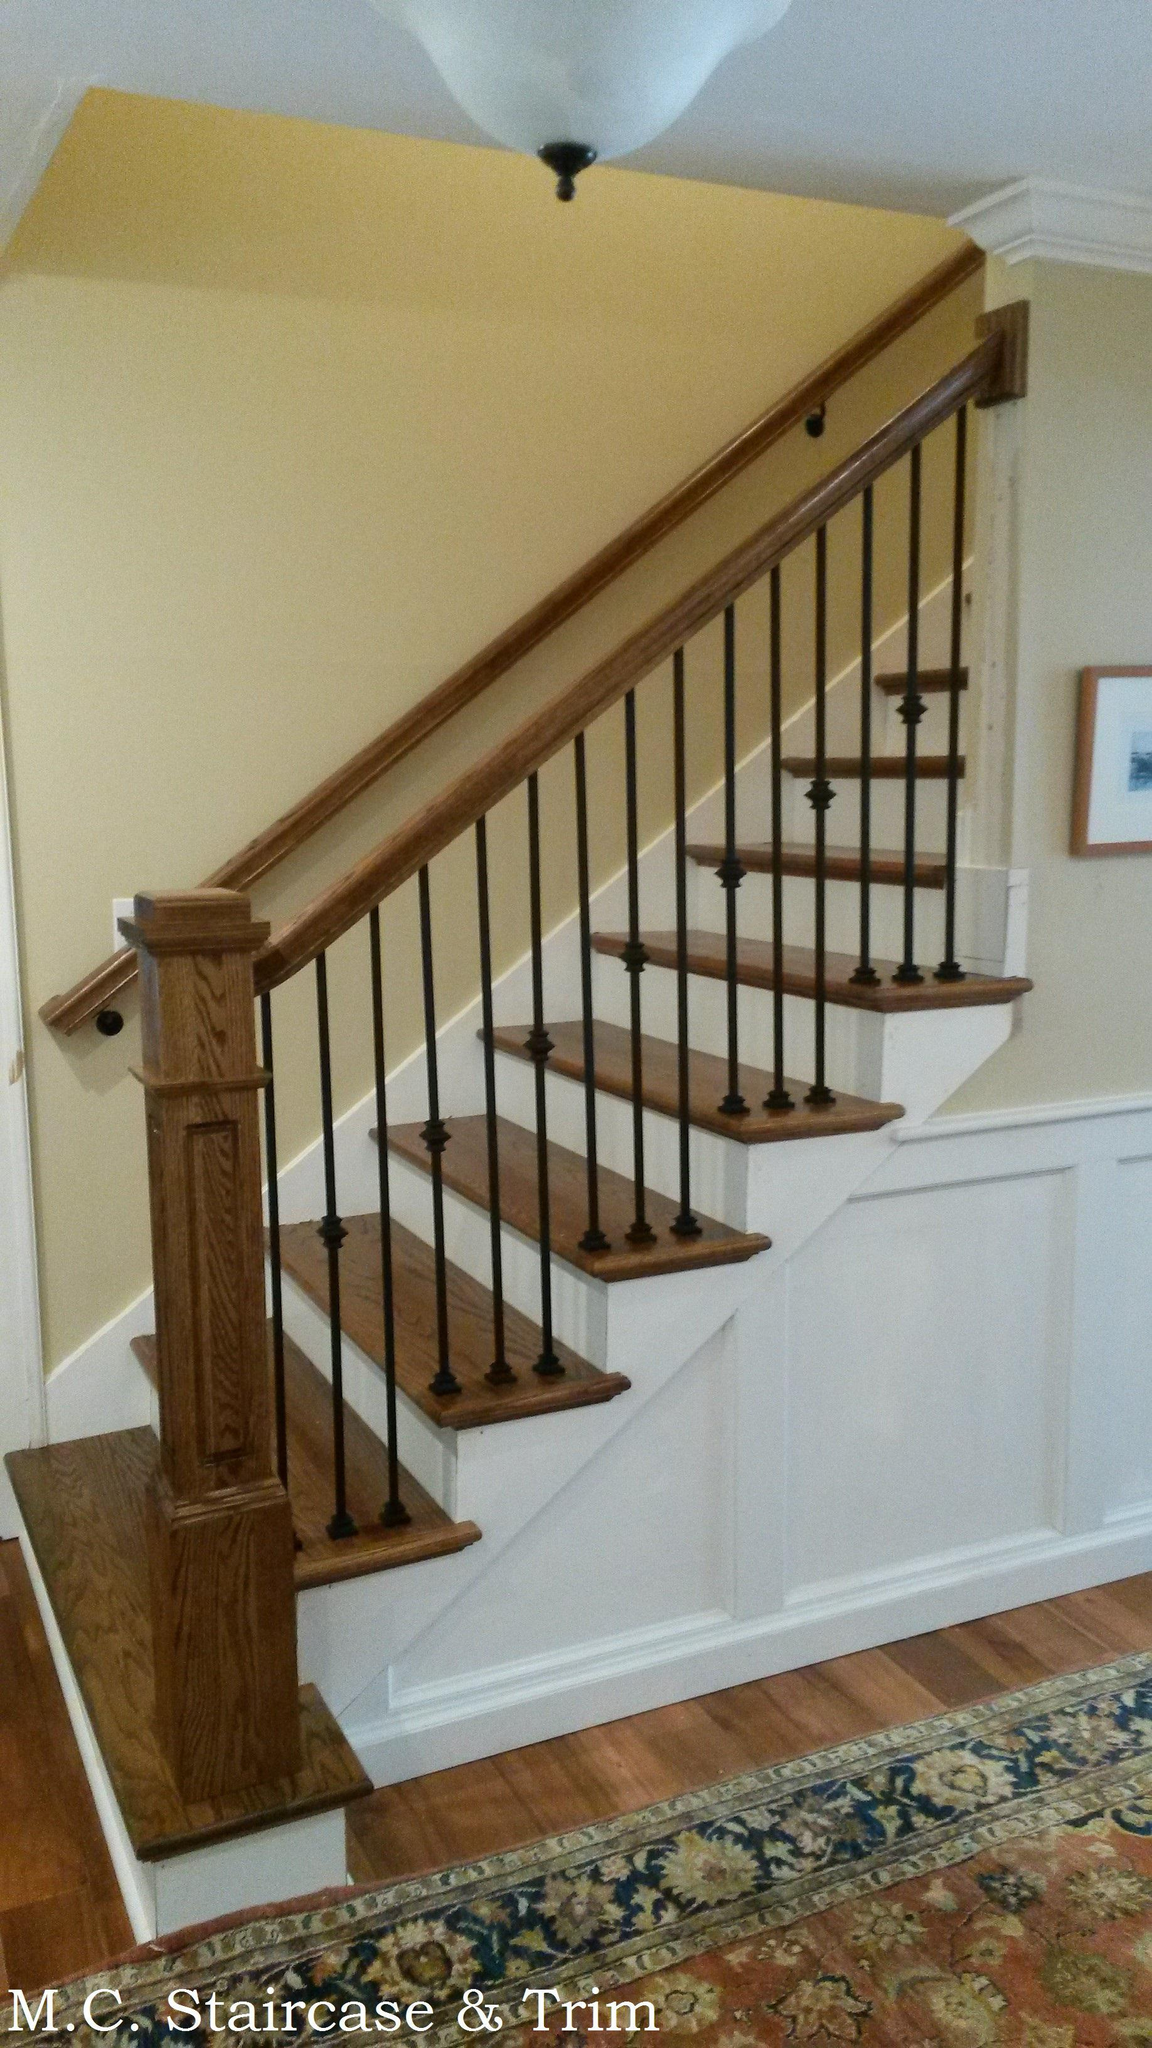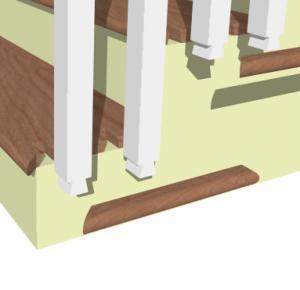The first image is the image on the left, the second image is the image on the right. For the images displayed, is the sentence "The right image shows a gate with vertical bars mounted to posts on each side to protect from falls, and a set of stairs is visible in the image." factually correct? Answer yes or no. No. The first image is the image on the left, the second image is the image on the right. For the images shown, is this caption "A staircase has wooden handles with black bars." true? Answer yes or no. Yes. 